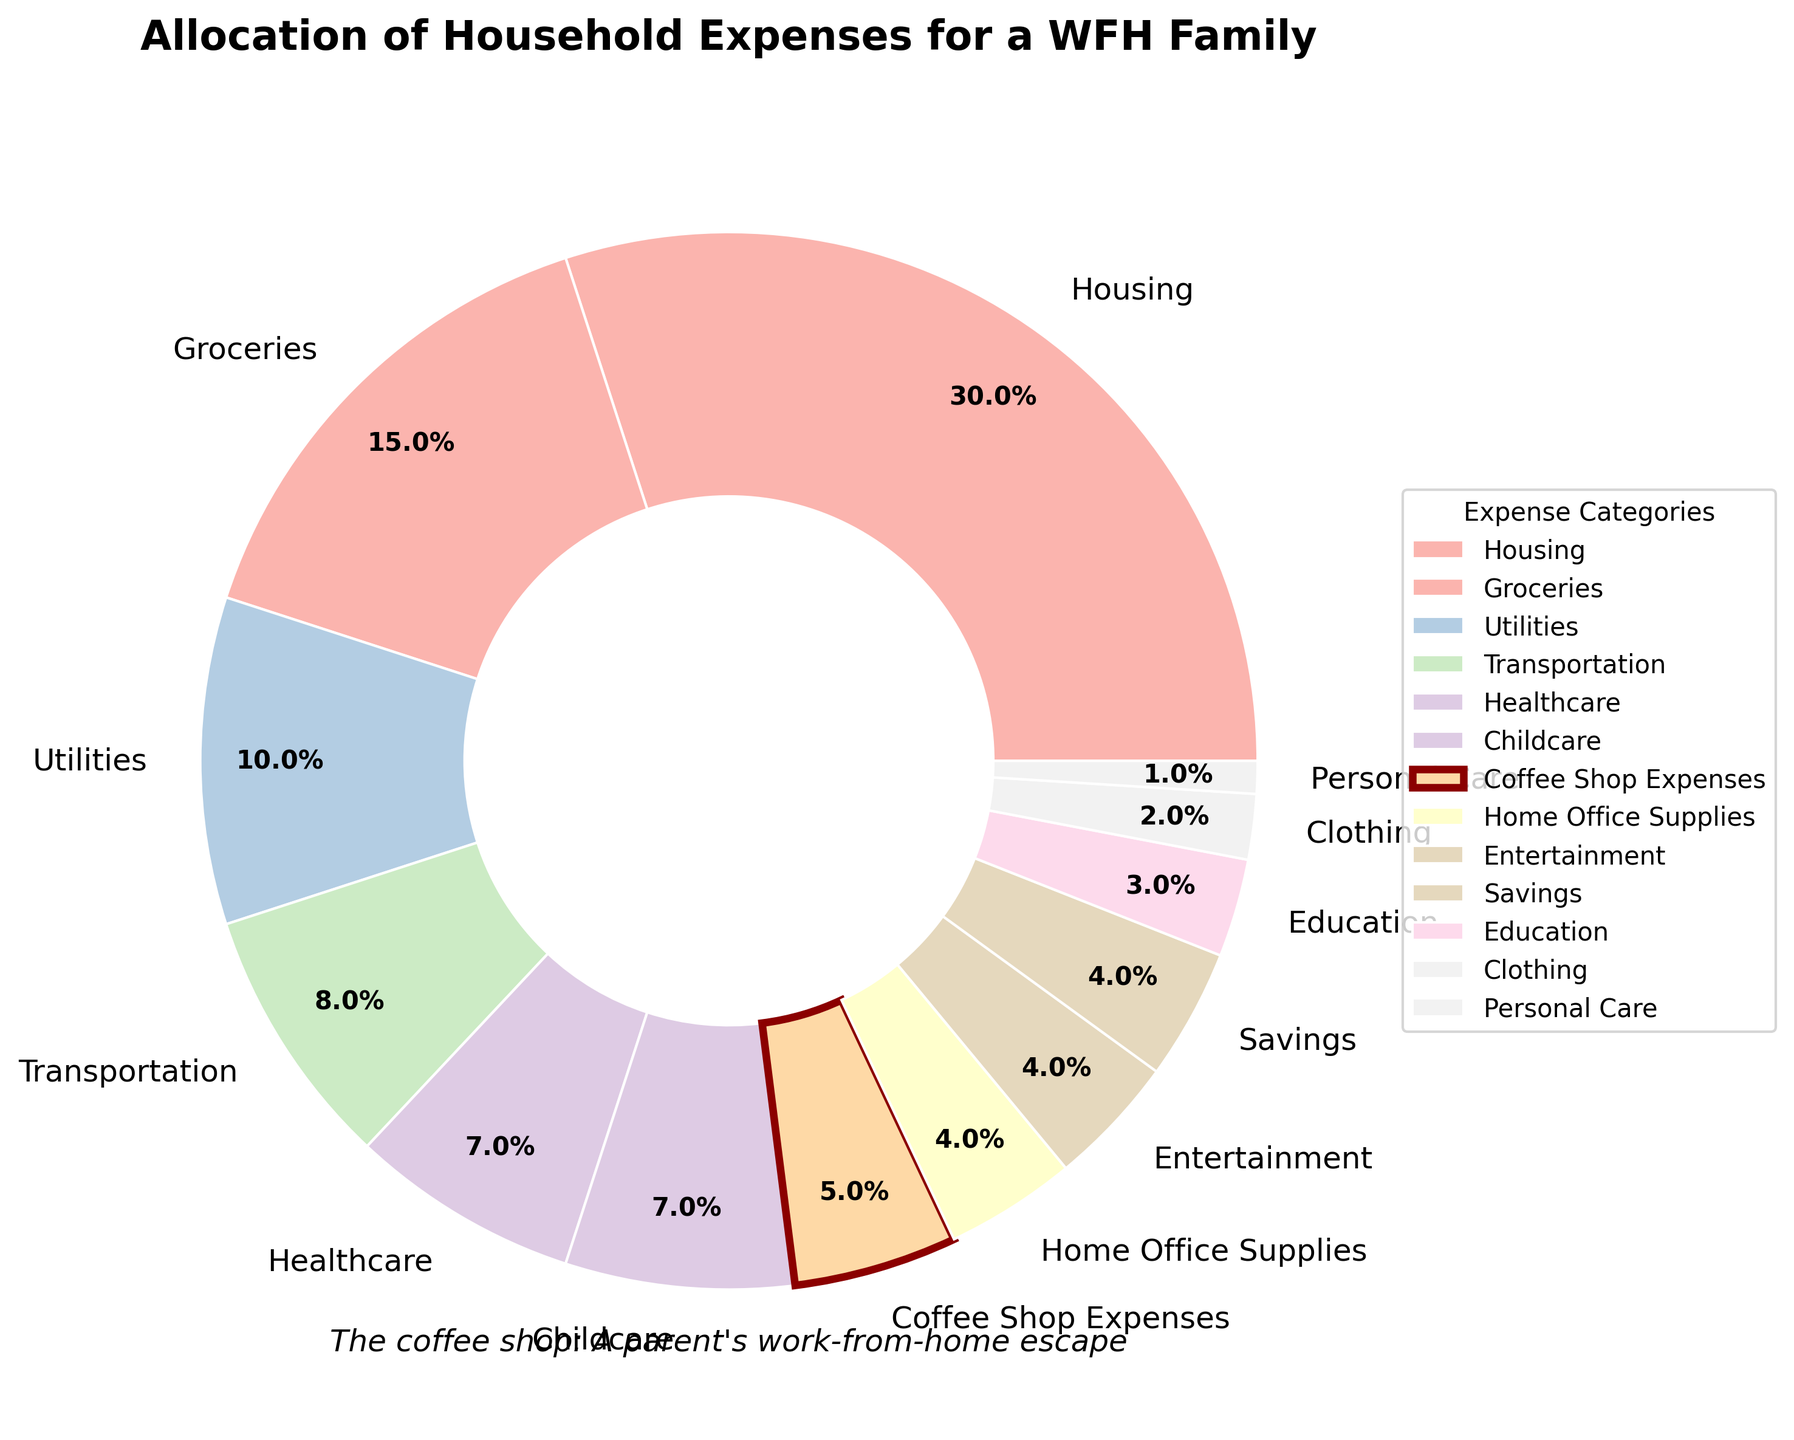What are the top three highest household expense categories? The top three highest household expense categories can be identified by looking at the slices of the pie chart with the largest percentages. These categories are Housing (30%), Groceries (15%), and Utilities (10%).
Answer: Housing, Groceries, Utilities How much more is spent on Housing compared to Coffee Shop Expenses? To find how much more is spent on Housing compared to Coffee Shop Expenses, subtract the percentage of Coffee Shop Expenses from the percentage of Housing. That is 30% - 5%.
Answer: 25% Which category has a smaller percentage allocation, Personal Care or Education? To identify which category has a smaller percentage allocation, compare the percentages of Personal Care (1%) and Education (3%). Personal Care is smaller.
Answer: Personal Care What is the combined percentage of Healthcare and Childcare expenses? To get the combined percentage of Healthcare and Childcare, add the percentages for these categories. That is 7% + 7%.
Answer: 14% How many categories have an allocation of 4%? To determine the number of categories with an allocation of 4%, count the categories listed with 4%. They are Home Office Supplies, Entertainment, and Savings. There are 3 such categories.
Answer: 3 Which slice represents Coffee Shop Expenses, and how is it visually distinct? The Coffee Shop Expenses slice represents 5% of the pie chart. It is visually distinct because its edge is highlighted in dark red and has a thicker boundary.
Answer: Dark red edge with a thicker boundary Is the allocation for Transportation greater than the combined allocation for Clothing and Personal Care? First, find the combined allocation for Clothing and Personal Care by adding 2% and 1%, which equals 3%. Compare this with the allocation for Transportation, which is 8%. Transportation is greater.
Answer: Yes What is the total percentage for all categories combined, excluding Housing, Groceries, and Utilities? First, sum the percentages of all the listed categories, which equals 100%. Subtract the percentages for Housing (30%), Groceries (15%), and Utilities (10%). The total is 100% - 55%.
Answer: 45% Which category is the closest to Coffee Shop Expenses as a percentage, and what is its value? Look at the percentages closest to Coffee Shop Expenses (5%). Since Home Office Supplies and Entertainment both have 4%, they are the closest.
Answer: Home Office Supplies, Entertainment; 4% How does the percentage allocated to Savings compare to that of Clothing? Compare the percentages for Savings (4%) and Clothing (2%). The percentage allocated to Savings is twice that of Clothing.
Answer: Savings is twice that of Clothing 